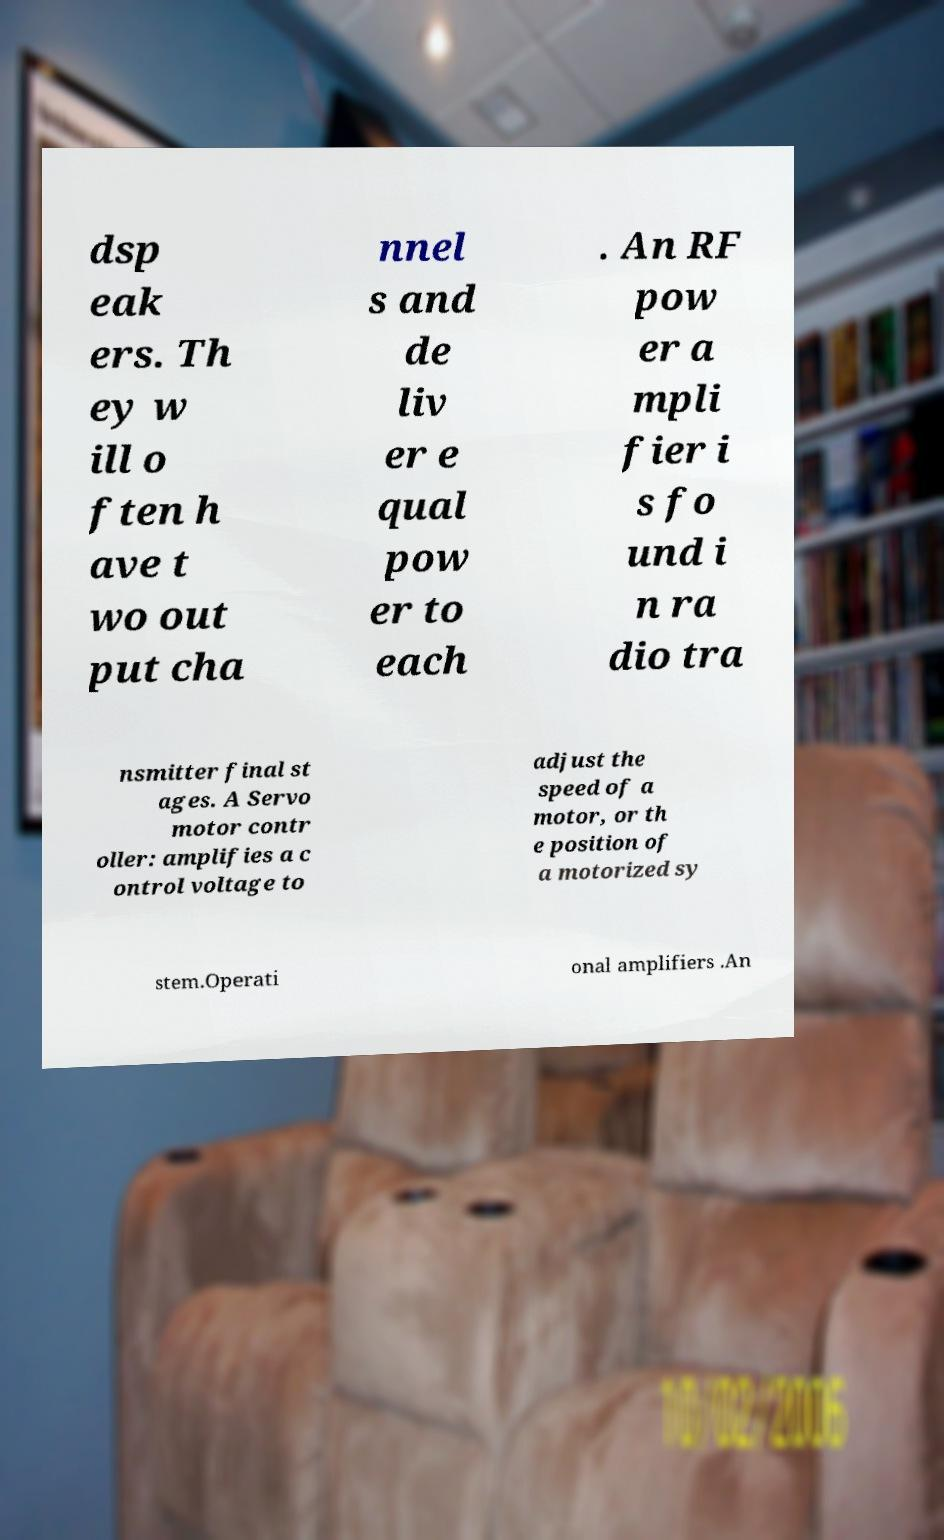Can you accurately transcribe the text from the provided image for me? dsp eak ers. Th ey w ill o ften h ave t wo out put cha nnel s and de liv er e qual pow er to each . An RF pow er a mpli fier i s fo und i n ra dio tra nsmitter final st ages. A Servo motor contr oller: amplifies a c ontrol voltage to adjust the speed of a motor, or th e position of a motorized sy stem.Operati onal amplifiers .An 